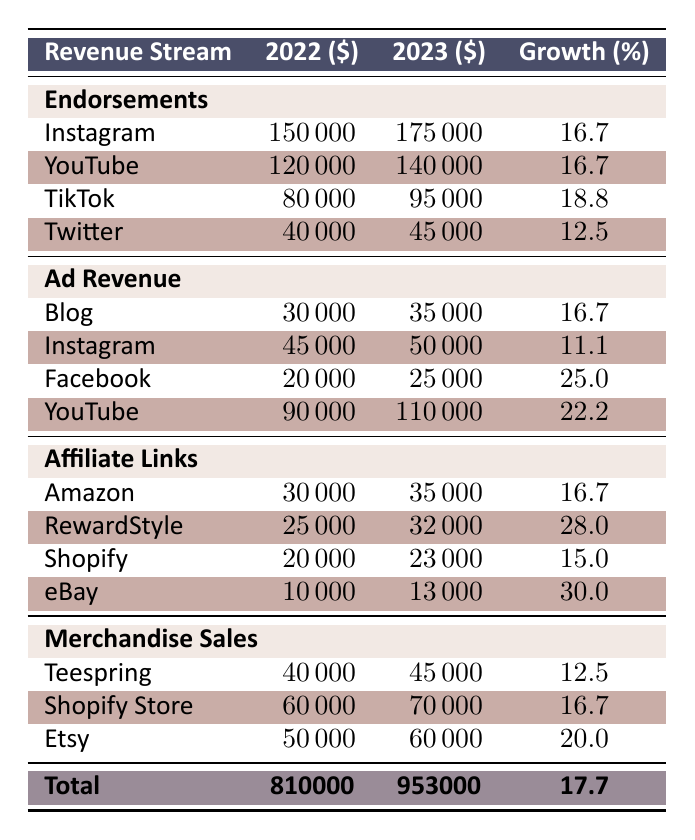What was the total revenue from merchandise sales in 2023? To find the total revenue from merchandise sales in 2023, I sum the values from the merchandise sales row: Teespring ($45000) + Shopify Store ($70000) + Etsy ($60000) = $45000 + $70000 + $60000 = $175000
Answer: 175000 Which revenue stream had the highest growth percentage from 2022 to 2023? By comparing the growth percentages across all the revenue streams, the highest growth percentage is found in eBay with 30.0%. I can see from the table that all growth percentages are listed, and eBay has the highest among them.
Answer: eBay Did Instagram endorsements grow more than 15% from 2022 to 2023? Looking at the endorsement row for Instagram, the value increased from $150000 to $175000. To calculate the growth percentage: (175000 - 150000) / 150000 * 100 = 16.7%, which is indeed greater than 15%.
Answer: Yes What is the difference in ad revenue from Facebook between 2022 and 2023? The ad revenue for Facebook in 2022 was $20000, and in 2023 it was $25000. To find the difference, I subtract the 2022 revenue from the 2023 revenue: $25000 - $20000 = $5000.
Answer: 5000 What is the total revenue across all streams for 2022? To find the total revenue for 2022, I need to sum all the revenue streams listed: Endorsements ($410000) + Ad Revenue ($185000) + Affiliate Links ($85000) + Merchandise Sales ($165000) = $410000 + $185000 + $85000 + $165000 = $810000.
Answer: 810000 Is TikTok the endorsement platform with the highest revenue in 2023? I can see that the TikTok endorsement revenue for 2023 is $95000. Comparing this with Instagram ($175000) and YouTube ($140000), TikTok does not have the highest. Hence, the statement is false.
Answer: No What was the total growth percentage for all revenue streams combined from 2022 to 2023? The total revenue for 2022 was $810000 and for 2023 it was $953000. The growth percentage is calculated as: (953000 - 810000) / 810000 * 100 = 17.7%. This shows the overall performance improvement combined across all streams.
Answer: 17.7 